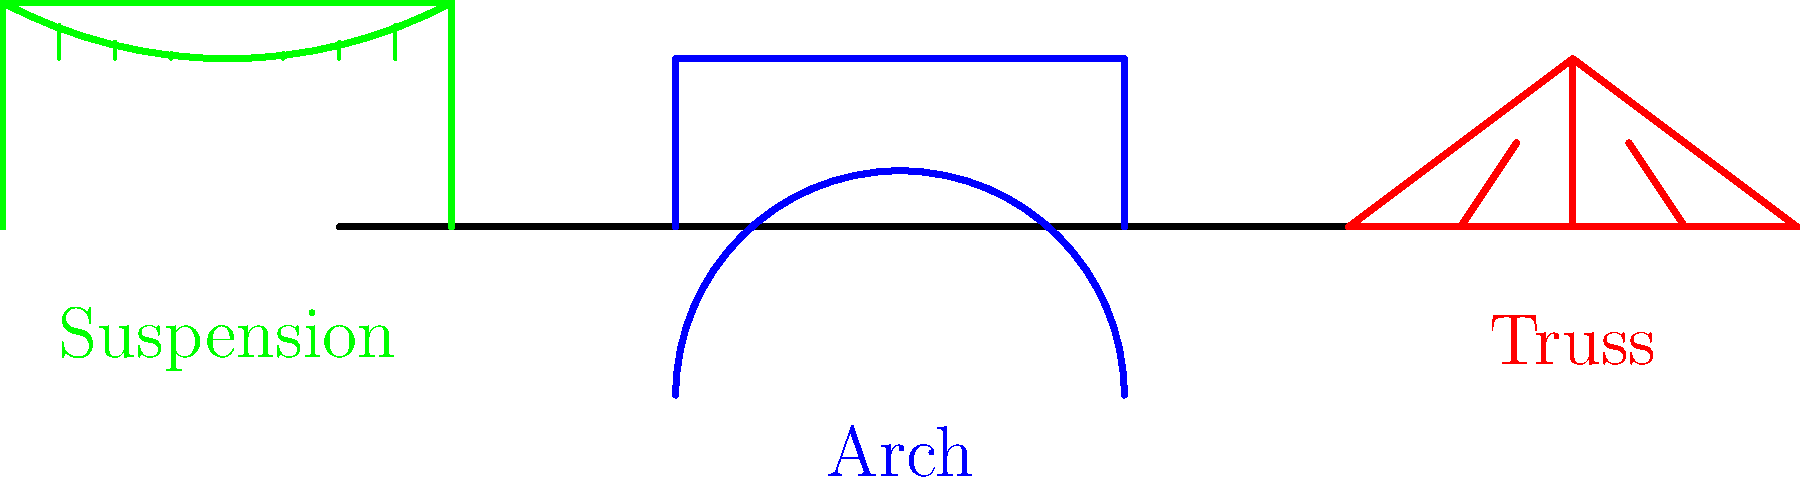As a neurologist who appreciates structural analogies, which of the three bridge designs shown (arch, truss, or suspension) would you consider most analogous to the brain's ability to redistribute function after localized damage, and why? To answer this question, we need to consider the characteristics of each bridge design and how they relate to the brain's ability to redistribute function:

1. Arch Bridge:
   - Distributes weight evenly across its structure
   - Relies on compression forces
   - Limited flexibility

2. Truss Bridge:
   - Uses a series of connected triangles to distribute forces
   - Efficient for shorter spans
   - Somewhat rigid structure

3. Suspension Bridge:
   - Uses cables to distribute weight over a large area
   - Highly flexible and adaptable to different loads
   - Can span long distances

The brain's ability to redistribute function after localized damage, known as neuroplasticity, is characterized by:
   - Flexibility in forming new neural connections
   - Ability to adapt to changes in structure and function
   - Distribution of tasks across different regions

Considering these factors, the suspension bridge is most analogous to the brain's ability to redistribute function because:
   - It has a flexible structure that can adapt to changes in load, similar to how the brain can adapt to changes in function.
   - The distribution of weight across a large area via cables is similar to how the brain can redistribute tasks across different regions.
   - Its ability to maintain stability even when parts of it are under stress is analogous to the brain's ability to maintain function despite localized damage.
Answer: Suspension bridge 